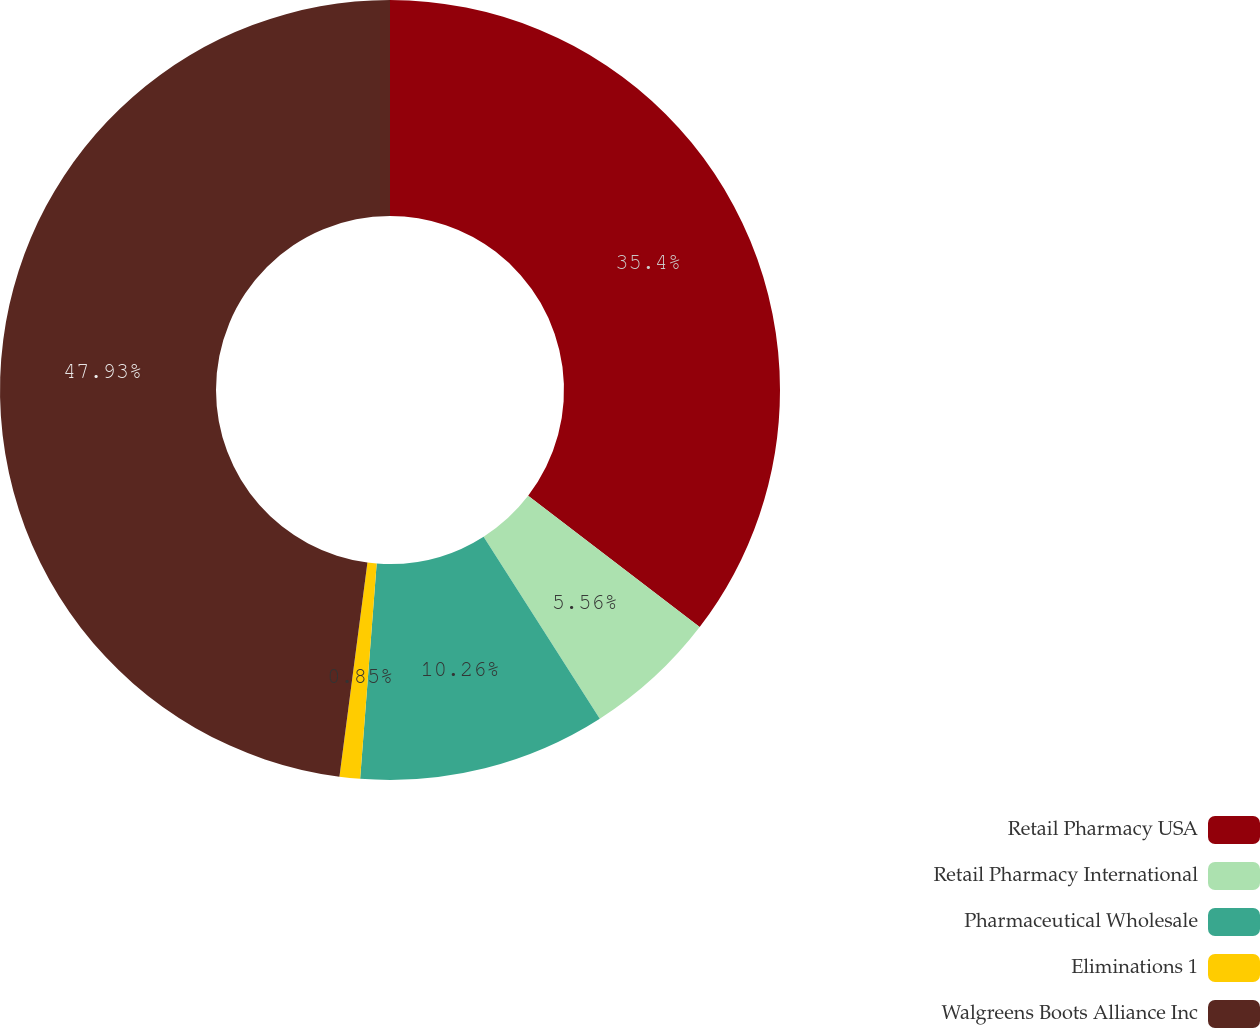<chart> <loc_0><loc_0><loc_500><loc_500><pie_chart><fcel>Retail Pharmacy USA<fcel>Retail Pharmacy International<fcel>Pharmaceutical Wholesale<fcel>Eliminations 1<fcel>Walgreens Boots Alliance Inc<nl><fcel>35.4%<fcel>5.56%<fcel>10.26%<fcel>0.85%<fcel>47.93%<nl></chart> 